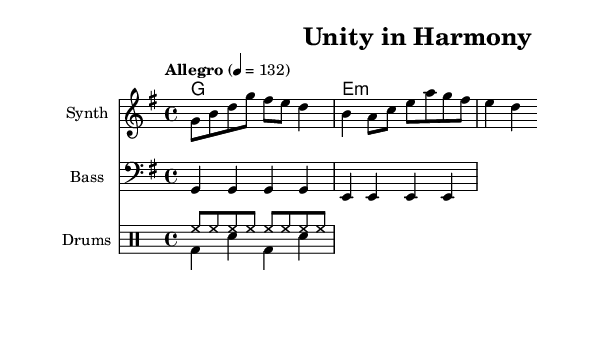What is the key signature of this music? The key signature is G major, which has one sharp (F#). This can be determined by looking at the key signature symbol at the beginning of the staff.
Answer: G major What is the time signature of the piece? The time signature is 4/4, indicated by the numbers at the beginning of the score. This means there are four beats in each measure, and the quarter note gets one beat.
Answer: 4/4 What is the tempo marking for this composition? The tempo marking is "Allegro" with a specific metronome marking of 132. This indicates a fast tempo, and the metronome marking provides a precise speed for the performance.
Answer: Allegro 132 How many measures are in the melody section? The melody consists of two measures, which can be counted by identifying the vertical bar lines that separate the measures in the staff. Each bar line indicates the end of a measure.
Answer: 2 What instruments are included in this score? The score includes a Synth for the melody, Bass, and Drums, as labeled at the beginning of the respective staves. Each instrument has its own staff for notation.
Answer: Synth, Bass, Drums What type of drum pattern is used in this piece? The drum section features a standard pattern, with a Hi-Hat pattern (hh) in eighth notes and a Bass Drum (bd) and Snare (sn) pattern in quarter notes. This combination is typical for an upbeat K-Pop style.
Answer: Upbeat Which chord is used in the harmony section? The harmony section features a G major chord indicated by the chord symbols. This can be confirmed by looking at the chord notation in the ChordNames staff at the start of the score.
Answer: G 